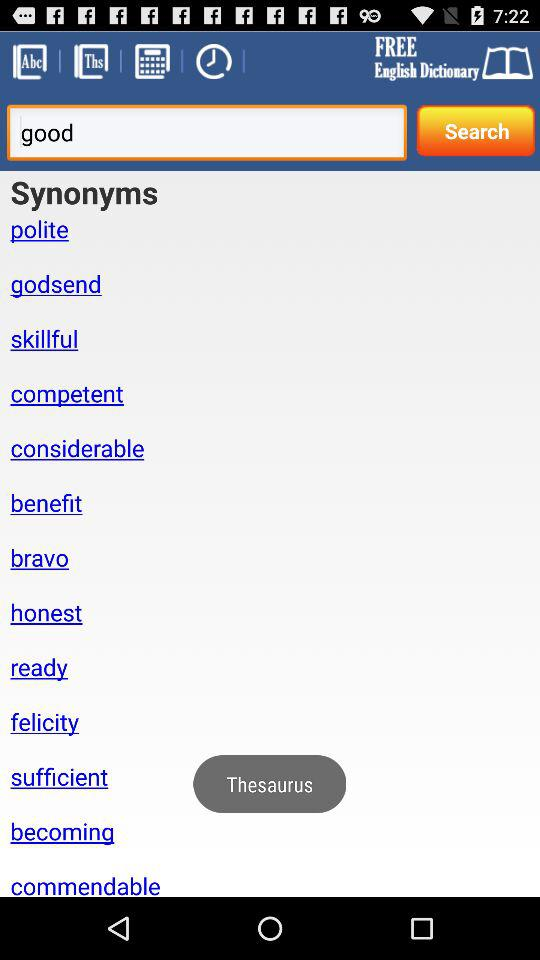What is the name of the application? The name of the application is "FREE English Dictionary". 